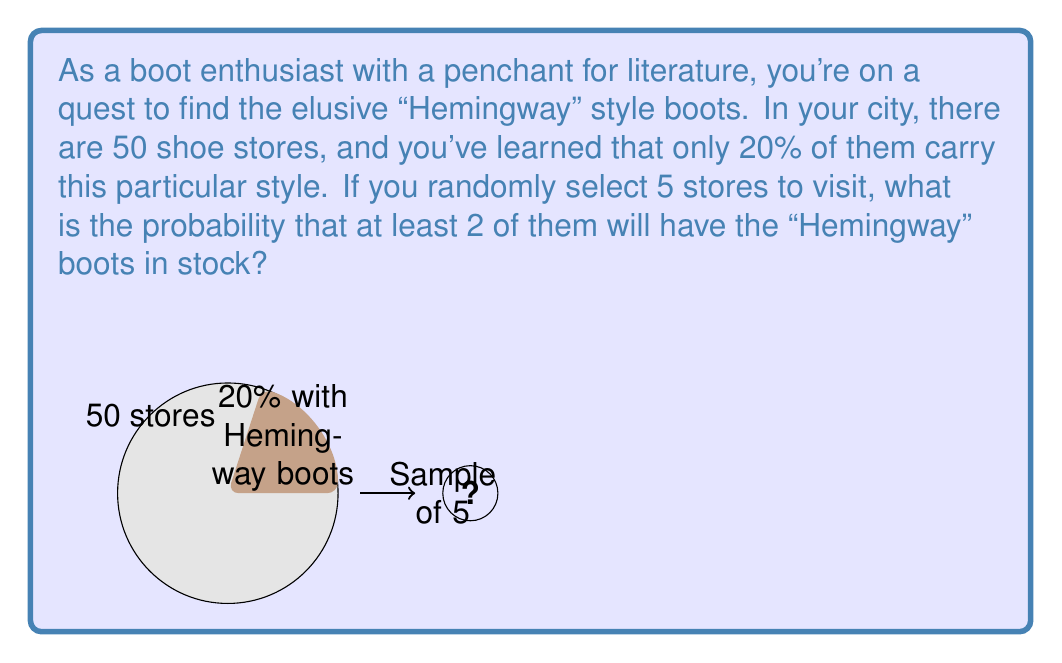Can you answer this question? Let's approach this step-by-step using the binomial probability distribution:

1) Define our variables:
   $n = 5$ (number of stores sampled)
   $p = 0.20$ (probability of a store having the boots)
   $q = 1 - p = 0.80$ (probability of a store not having the boots)

2) We want the probability of at least 2 successes, which is equivalent to 1 minus the probability of 0 or 1 success.

3) The probability mass function for a binomial distribution is:

   $P(X=k) = \binom{n}{k} p^k q^{n-k}$

4) Calculate the probability of 0 successes:
   $P(X=0) = \binom{5}{0} (0.20)^0 (0.80)^5 = 1 \cdot 1 \cdot 0.32768 = 0.32768$

5) Calculate the probability of 1 success:
   $P(X=1) = \binom{5}{1} (0.20)^1 (0.80)^4 = 5 \cdot 0.20 \cdot 0.4096 = 0.4096$

6) The probability of at least 2 successes is:
   $P(X \geq 2) = 1 - P(X=0) - P(X=1)$
   $= 1 - 0.32768 - 0.4096$
   $= 1 - 0.73728$
   $= 0.26272$

Therefore, the probability of finding the "Hemingway" boots in at least 2 out of 5 randomly selected stores is approximately 0.26272 or 26.27%.
Answer: 0.26272 